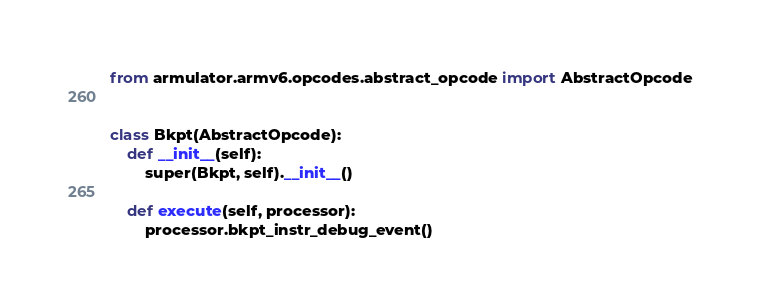<code> <loc_0><loc_0><loc_500><loc_500><_Python_>from armulator.armv6.opcodes.abstract_opcode import AbstractOpcode


class Bkpt(AbstractOpcode):
    def __init__(self):
        super(Bkpt, self).__init__()

    def execute(self, processor):
        processor.bkpt_instr_debug_event()
</code> 